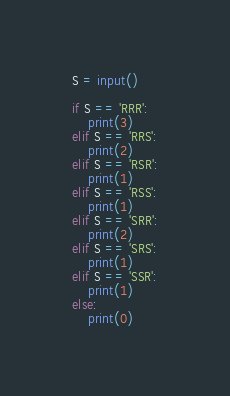<code> <loc_0><loc_0><loc_500><loc_500><_Python_>S = input()

if S == 'RRR':
    print(3)
elif S == 'RRS':
    print(2)
elif S == 'RSR':
    print(1)
elif S == 'RSS':
    print(1)
elif S == 'SRR':
    print(2)
elif S == 'SRS':
    print(1)
elif S == 'SSR':
    print(1)
else:
    print(0)
</code> 